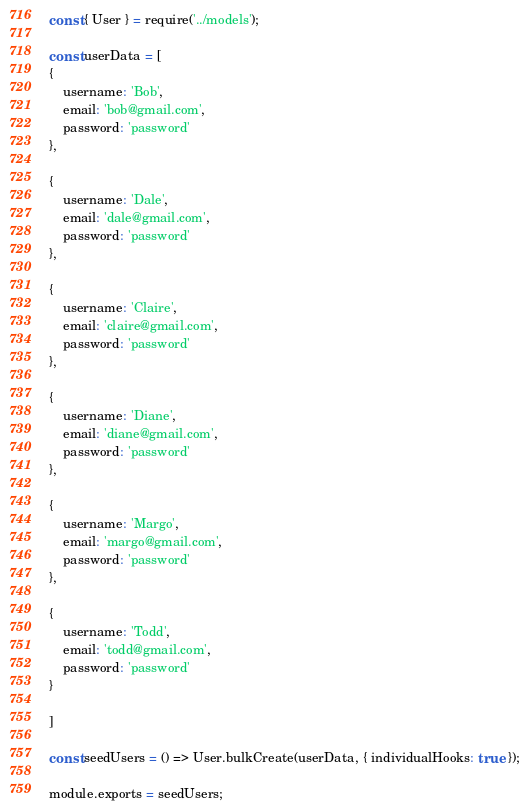<code> <loc_0><loc_0><loc_500><loc_500><_JavaScript_>const { User } = require('../models');

const userData = [
{
    username: 'Bob',    
    email: 'bob@gmail.com',
    password: 'password'
},

{
    username: 'Dale',    
    email: 'dale@gmail.com',
    password: 'password'
},

{
    username: 'Claire',    
    email: 'claire@gmail.com',
    password: 'password'
},

{
    username: 'Diane',    
    email: 'diane@gmail.com',
    password: 'password'
},

{
    username: 'Margo',    
    email: 'margo@gmail.com',
    password: 'password'
},

{
    username: 'Todd',    
    email: 'todd@gmail.com',
    password: 'password'
}

]

const seedUsers = () => User.bulkCreate(userData, { individualHooks: true });

module.exports = seedUsers;</code> 